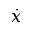<formula> <loc_0><loc_0><loc_500><loc_500>\dot { x }</formula> 